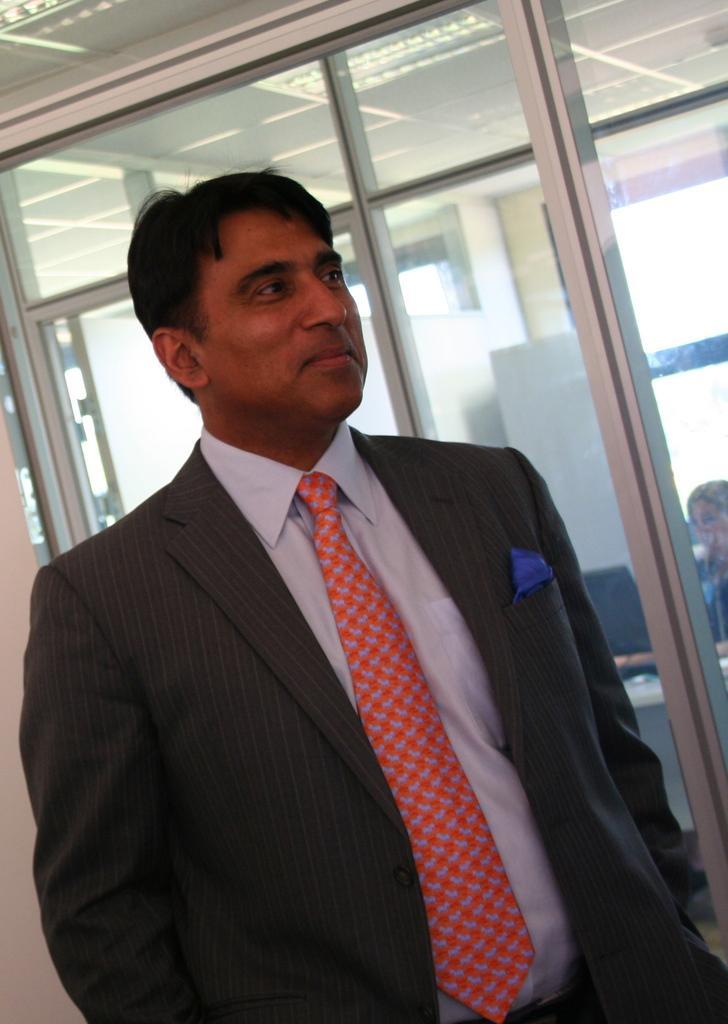In one or two sentences, can you explain what this image depicts? In this image we can see a person with a smiling face and behind him we can see the glass door. 